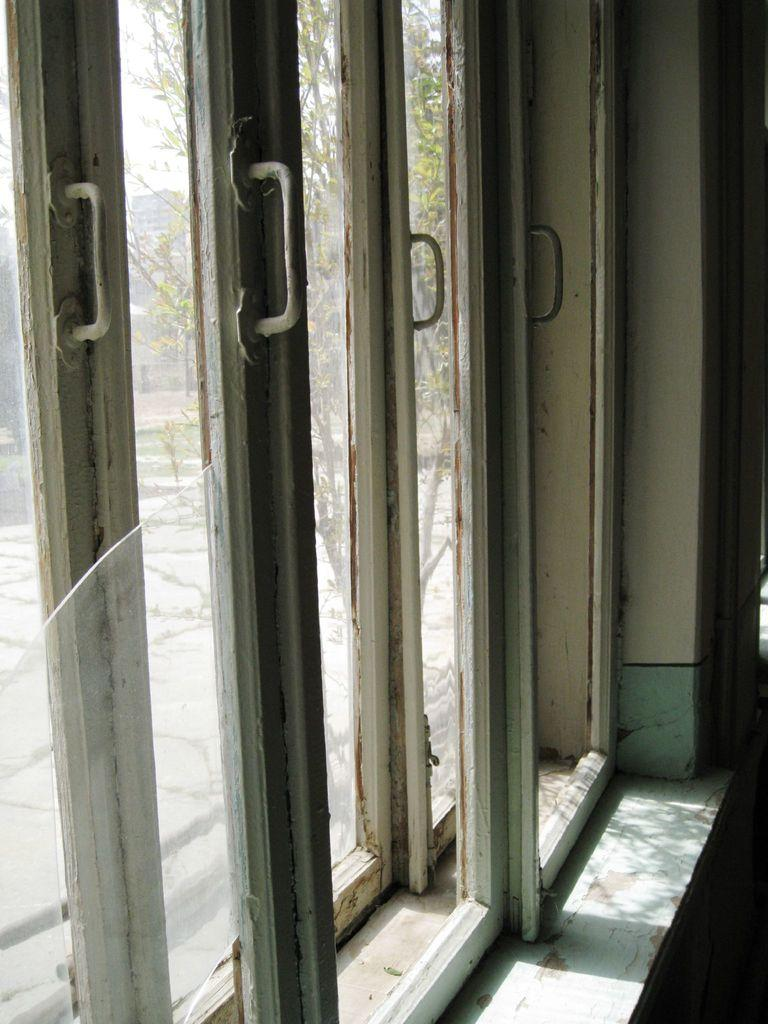What type of doors are present in the image? There are glass doors in the image. What can be seen through the glass doors? Trees, a building, and the sky are visible through the glass doors. Can you describe the background visible through the glass doors? The background includes trees, a building, and the sky. Are there any stamps visible on the glass doors in the image? There are no stamps present on the glass doors in the image. Can you see any fairies flying around the trees in the image? There are no fairies visible in the image; only trees, a building, and the sky are present. 